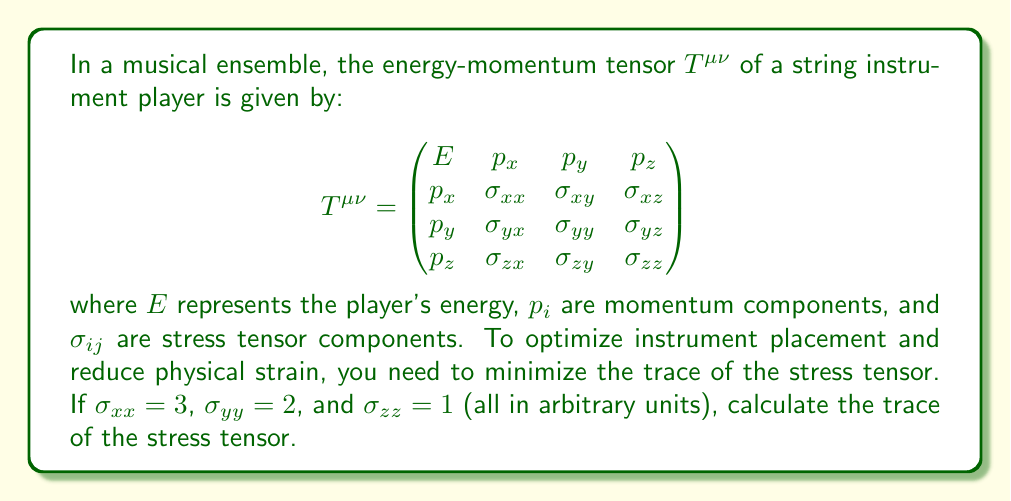Can you solve this math problem? To solve this problem, we'll follow these steps:

1) The trace of a tensor is the sum of its diagonal elements. For the stress tensor, this means we need to sum $\sigma_{xx}$, $\sigma_{yy}$, and $\sigma_{zz}$.

2) We are given the following values:
   $\sigma_{xx} = 3$
   $\sigma_{yy} = 2$
   $\sigma_{zz} = 1$

3) The trace of the stress tensor, let's call it $Tr(\sigma)$, is:

   $Tr(\sigma) = \sigma_{xx} + \sigma_{yy} + \sigma_{zz}$

4) Substituting the given values:

   $Tr(\sigma) = 3 + 2 + 1$

5) Calculating the sum:

   $Tr(\sigma) = 6$

This value represents the total "strain" experienced by the player. A lower value would indicate less physical strain, which is the goal for optimizing instrument placement.
Answer: $6$ 